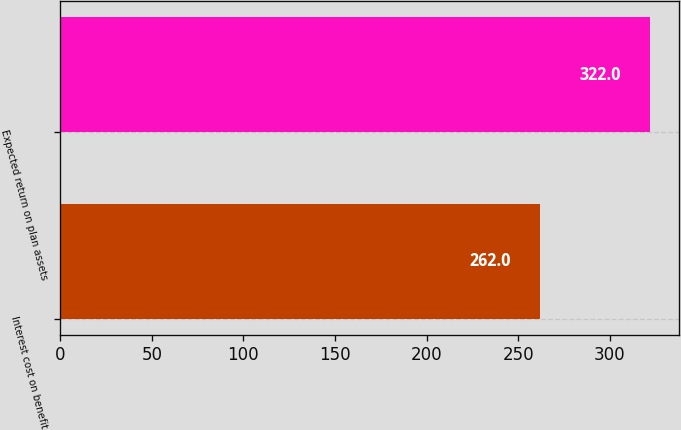Convert chart to OTSL. <chart><loc_0><loc_0><loc_500><loc_500><bar_chart><fcel>Interest cost on benefit<fcel>Expected return on plan assets<nl><fcel>262<fcel>322<nl></chart> 